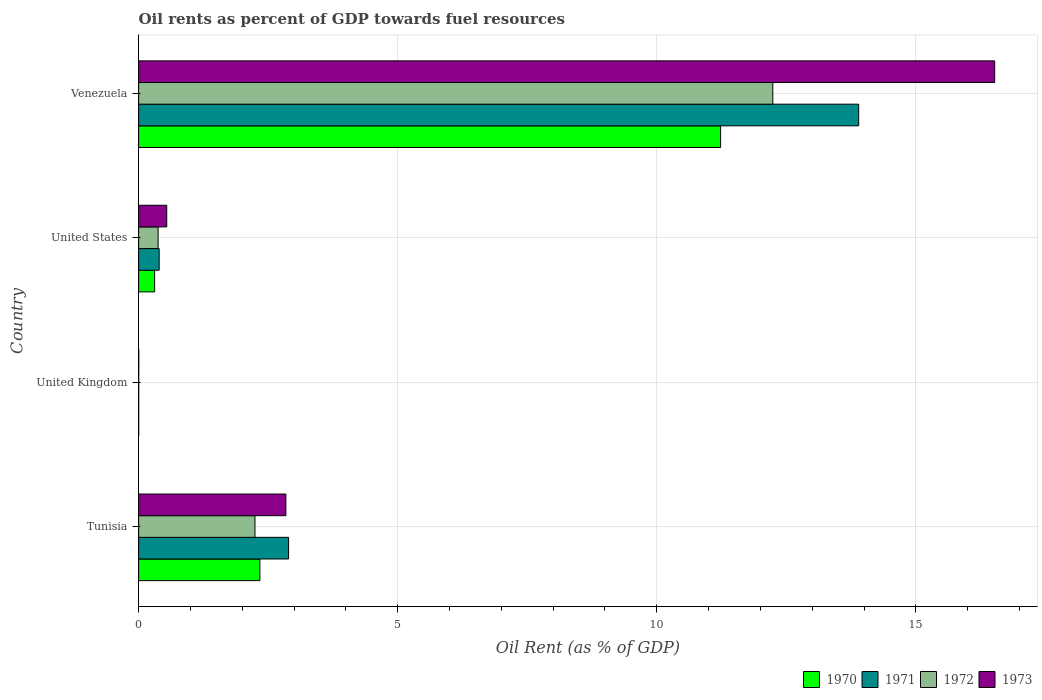How many different coloured bars are there?
Your answer should be very brief. 4. How many groups of bars are there?
Your answer should be compact. 4. Are the number of bars on each tick of the Y-axis equal?
Your answer should be compact. Yes. How many bars are there on the 3rd tick from the bottom?
Provide a short and direct response. 4. In how many cases, is the number of bars for a given country not equal to the number of legend labels?
Provide a short and direct response. 0. What is the oil rent in 1970 in Venezuela?
Give a very brief answer. 11.23. Across all countries, what is the maximum oil rent in 1970?
Keep it short and to the point. 11.23. Across all countries, what is the minimum oil rent in 1971?
Your answer should be very brief. 0. In which country was the oil rent in 1971 maximum?
Make the answer very short. Venezuela. In which country was the oil rent in 1971 minimum?
Your answer should be very brief. United Kingdom. What is the total oil rent in 1973 in the graph?
Provide a succinct answer. 19.91. What is the difference between the oil rent in 1970 in Tunisia and that in United States?
Offer a very short reply. 2.03. What is the difference between the oil rent in 1973 in United States and the oil rent in 1971 in Venezuela?
Offer a very short reply. -13.35. What is the average oil rent in 1972 per country?
Ensure brevity in your answer.  3.72. What is the difference between the oil rent in 1972 and oil rent in 1970 in United Kingdom?
Ensure brevity in your answer.  0. What is the ratio of the oil rent in 1973 in Tunisia to that in Venezuela?
Your answer should be very brief. 0.17. What is the difference between the highest and the second highest oil rent in 1973?
Provide a succinct answer. 13.68. What is the difference between the highest and the lowest oil rent in 1971?
Offer a terse response. 13.9. What does the 4th bar from the top in Tunisia represents?
Make the answer very short. 1970. What does the 2nd bar from the bottom in United Kingdom represents?
Keep it short and to the point. 1971. Is it the case that in every country, the sum of the oil rent in 1970 and oil rent in 1973 is greater than the oil rent in 1971?
Ensure brevity in your answer.  Yes. Are all the bars in the graph horizontal?
Provide a short and direct response. Yes. What is the difference between two consecutive major ticks on the X-axis?
Provide a short and direct response. 5. How are the legend labels stacked?
Your answer should be very brief. Horizontal. What is the title of the graph?
Offer a terse response. Oil rents as percent of GDP towards fuel resources. Does "1970" appear as one of the legend labels in the graph?
Ensure brevity in your answer.  Yes. What is the label or title of the X-axis?
Offer a very short reply. Oil Rent (as % of GDP). What is the label or title of the Y-axis?
Offer a very short reply. Country. What is the Oil Rent (as % of GDP) of 1970 in Tunisia?
Ensure brevity in your answer.  2.34. What is the Oil Rent (as % of GDP) in 1971 in Tunisia?
Offer a very short reply. 2.89. What is the Oil Rent (as % of GDP) in 1972 in Tunisia?
Offer a terse response. 2.25. What is the Oil Rent (as % of GDP) in 1973 in Tunisia?
Your answer should be very brief. 2.84. What is the Oil Rent (as % of GDP) in 1970 in United Kingdom?
Ensure brevity in your answer.  0. What is the Oil Rent (as % of GDP) in 1971 in United Kingdom?
Your response must be concise. 0. What is the Oil Rent (as % of GDP) of 1972 in United Kingdom?
Make the answer very short. 0. What is the Oil Rent (as % of GDP) of 1973 in United Kingdom?
Your response must be concise. 0. What is the Oil Rent (as % of GDP) of 1970 in United States?
Offer a very short reply. 0.31. What is the Oil Rent (as % of GDP) in 1971 in United States?
Ensure brevity in your answer.  0.4. What is the Oil Rent (as % of GDP) of 1972 in United States?
Provide a short and direct response. 0.38. What is the Oil Rent (as % of GDP) in 1973 in United States?
Your response must be concise. 0.54. What is the Oil Rent (as % of GDP) of 1970 in Venezuela?
Provide a succinct answer. 11.23. What is the Oil Rent (as % of GDP) of 1971 in Venezuela?
Keep it short and to the point. 13.9. What is the Oil Rent (as % of GDP) in 1972 in Venezuela?
Offer a terse response. 12.24. What is the Oil Rent (as % of GDP) in 1973 in Venezuela?
Make the answer very short. 16.52. Across all countries, what is the maximum Oil Rent (as % of GDP) of 1970?
Offer a very short reply. 11.23. Across all countries, what is the maximum Oil Rent (as % of GDP) of 1971?
Your answer should be compact. 13.9. Across all countries, what is the maximum Oil Rent (as % of GDP) of 1972?
Keep it short and to the point. 12.24. Across all countries, what is the maximum Oil Rent (as % of GDP) of 1973?
Provide a succinct answer. 16.52. Across all countries, what is the minimum Oil Rent (as % of GDP) in 1970?
Make the answer very short. 0. Across all countries, what is the minimum Oil Rent (as % of GDP) in 1971?
Ensure brevity in your answer.  0. Across all countries, what is the minimum Oil Rent (as % of GDP) in 1972?
Your response must be concise. 0. Across all countries, what is the minimum Oil Rent (as % of GDP) of 1973?
Make the answer very short. 0. What is the total Oil Rent (as % of GDP) of 1970 in the graph?
Keep it short and to the point. 13.88. What is the total Oil Rent (as % of GDP) of 1971 in the graph?
Your answer should be very brief. 17.19. What is the total Oil Rent (as % of GDP) in 1972 in the graph?
Give a very brief answer. 14.86. What is the total Oil Rent (as % of GDP) of 1973 in the graph?
Ensure brevity in your answer.  19.91. What is the difference between the Oil Rent (as % of GDP) of 1970 in Tunisia and that in United Kingdom?
Offer a very short reply. 2.34. What is the difference between the Oil Rent (as % of GDP) of 1971 in Tunisia and that in United Kingdom?
Your response must be concise. 2.89. What is the difference between the Oil Rent (as % of GDP) in 1972 in Tunisia and that in United Kingdom?
Ensure brevity in your answer.  2.24. What is the difference between the Oil Rent (as % of GDP) of 1973 in Tunisia and that in United Kingdom?
Provide a succinct answer. 2.84. What is the difference between the Oil Rent (as % of GDP) of 1970 in Tunisia and that in United States?
Offer a terse response. 2.03. What is the difference between the Oil Rent (as % of GDP) of 1971 in Tunisia and that in United States?
Keep it short and to the point. 2.5. What is the difference between the Oil Rent (as % of GDP) of 1972 in Tunisia and that in United States?
Offer a very short reply. 1.87. What is the difference between the Oil Rent (as % of GDP) of 1973 in Tunisia and that in United States?
Ensure brevity in your answer.  2.3. What is the difference between the Oil Rent (as % of GDP) in 1970 in Tunisia and that in Venezuela?
Offer a very short reply. -8.89. What is the difference between the Oil Rent (as % of GDP) of 1971 in Tunisia and that in Venezuela?
Give a very brief answer. -11. What is the difference between the Oil Rent (as % of GDP) in 1972 in Tunisia and that in Venezuela?
Make the answer very short. -9.99. What is the difference between the Oil Rent (as % of GDP) in 1973 in Tunisia and that in Venezuela?
Provide a short and direct response. -13.68. What is the difference between the Oil Rent (as % of GDP) of 1970 in United Kingdom and that in United States?
Make the answer very short. -0.31. What is the difference between the Oil Rent (as % of GDP) of 1971 in United Kingdom and that in United States?
Offer a very short reply. -0.4. What is the difference between the Oil Rent (as % of GDP) in 1972 in United Kingdom and that in United States?
Your response must be concise. -0.37. What is the difference between the Oil Rent (as % of GDP) of 1973 in United Kingdom and that in United States?
Your response must be concise. -0.54. What is the difference between the Oil Rent (as % of GDP) of 1970 in United Kingdom and that in Venezuela?
Offer a very short reply. -11.23. What is the difference between the Oil Rent (as % of GDP) of 1971 in United Kingdom and that in Venezuela?
Offer a terse response. -13.9. What is the difference between the Oil Rent (as % of GDP) of 1972 in United Kingdom and that in Venezuela?
Give a very brief answer. -12.24. What is the difference between the Oil Rent (as % of GDP) of 1973 in United Kingdom and that in Venezuela?
Ensure brevity in your answer.  -16.52. What is the difference between the Oil Rent (as % of GDP) of 1970 in United States and that in Venezuela?
Offer a terse response. -10.92. What is the difference between the Oil Rent (as % of GDP) in 1971 in United States and that in Venezuela?
Make the answer very short. -13.5. What is the difference between the Oil Rent (as % of GDP) of 1972 in United States and that in Venezuela?
Your answer should be compact. -11.86. What is the difference between the Oil Rent (as % of GDP) of 1973 in United States and that in Venezuela?
Your response must be concise. -15.98. What is the difference between the Oil Rent (as % of GDP) of 1970 in Tunisia and the Oil Rent (as % of GDP) of 1971 in United Kingdom?
Offer a terse response. 2.34. What is the difference between the Oil Rent (as % of GDP) of 1970 in Tunisia and the Oil Rent (as % of GDP) of 1972 in United Kingdom?
Keep it short and to the point. 2.34. What is the difference between the Oil Rent (as % of GDP) of 1970 in Tunisia and the Oil Rent (as % of GDP) of 1973 in United Kingdom?
Your response must be concise. 2.34. What is the difference between the Oil Rent (as % of GDP) of 1971 in Tunisia and the Oil Rent (as % of GDP) of 1972 in United Kingdom?
Provide a succinct answer. 2.89. What is the difference between the Oil Rent (as % of GDP) in 1971 in Tunisia and the Oil Rent (as % of GDP) in 1973 in United Kingdom?
Offer a terse response. 2.89. What is the difference between the Oil Rent (as % of GDP) of 1972 in Tunisia and the Oil Rent (as % of GDP) of 1973 in United Kingdom?
Give a very brief answer. 2.24. What is the difference between the Oil Rent (as % of GDP) of 1970 in Tunisia and the Oil Rent (as % of GDP) of 1971 in United States?
Provide a short and direct response. 1.94. What is the difference between the Oil Rent (as % of GDP) of 1970 in Tunisia and the Oil Rent (as % of GDP) of 1972 in United States?
Provide a short and direct response. 1.96. What is the difference between the Oil Rent (as % of GDP) of 1970 in Tunisia and the Oil Rent (as % of GDP) of 1973 in United States?
Offer a very short reply. 1.8. What is the difference between the Oil Rent (as % of GDP) in 1971 in Tunisia and the Oil Rent (as % of GDP) in 1972 in United States?
Provide a short and direct response. 2.52. What is the difference between the Oil Rent (as % of GDP) of 1971 in Tunisia and the Oil Rent (as % of GDP) of 1973 in United States?
Give a very brief answer. 2.35. What is the difference between the Oil Rent (as % of GDP) in 1972 in Tunisia and the Oil Rent (as % of GDP) in 1973 in United States?
Offer a very short reply. 1.7. What is the difference between the Oil Rent (as % of GDP) of 1970 in Tunisia and the Oil Rent (as % of GDP) of 1971 in Venezuela?
Your answer should be compact. -11.56. What is the difference between the Oil Rent (as % of GDP) in 1970 in Tunisia and the Oil Rent (as % of GDP) in 1972 in Venezuela?
Your response must be concise. -9.9. What is the difference between the Oil Rent (as % of GDP) in 1970 in Tunisia and the Oil Rent (as % of GDP) in 1973 in Venezuela?
Offer a very short reply. -14.18. What is the difference between the Oil Rent (as % of GDP) of 1971 in Tunisia and the Oil Rent (as % of GDP) of 1972 in Venezuela?
Offer a terse response. -9.35. What is the difference between the Oil Rent (as % of GDP) of 1971 in Tunisia and the Oil Rent (as % of GDP) of 1973 in Venezuela?
Offer a terse response. -13.63. What is the difference between the Oil Rent (as % of GDP) of 1972 in Tunisia and the Oil Rent (as % of GDP) of 1973 in Venezuela?
Your response must be concise. -14.28. What is the difference between the Oil Rent (as % of GDP) of 1970 in United Kingdom and the Oil Rent (as % of GDP) of 1971 in United States?
Keep it short and to the point. -0.4. What is the difference between the Oil Rent (as % of GDP) in 1970 in United Kingdom and the Oil Rent (as % of GDP) in 1972 in United States?
Give a very brief answer. -0.38. What is the difference between the Oil Rent (as % of GDP) of 1970 in United Kingdom and the Oil Rent (as % of GDP) of 1973 in United States?
Offer a terse response. -0.54. What is the difference between the Oil Rent (as % of GDP) in 1971 in United Kingdom and the Oil Rent (as % of GDP) in 1972 in United States?
Offer a terse response. -0.38. What is the difference between the Oil Rent (as % of GDP) of 1971 in United Kingdom and the Oil Rent (as % of GDP) of 1973 in United States?
Keep it short and to the point. -0.54. What is the difference between the Oil Rent (as % of GDP) in 1972 in United Kingdom and the Oil Rent (as % of GDP) in 1973 in United States?
Ensure brevity in your answer.  -0.54. What is the difference between the Oil Rent (as % of GDP) in 1970 in United Kingdom and the Oil Rent (as % of GDP) in 1971 in Venezuela?
Offer a very short reply. -13.9. What is the difference between the Oil Rent (as % of GDP) in 1970 in United Kingdom and the Oil Rent (as % of GDP) in 1972 in Venezuela?
Offer a terse response. -12.24. What is the difference between the Oil Rent (as % of GDP) in 1970 in United Kingdom and the Oil Rent (as % of GDP) in 1973 in Venezuela?
Make the answer very short. -16.52. What is the difference between the Oil Rent (as % of GDP) of 1971 in United Kingdom and the Oil Rent (as % of GDP) of 1972 in Venezuela?
Provide a succinct answer. -12.24. What is the difference between the Oil Rent (as % of GDP) of 1971 in United Kingdom and the Oil Rent (as % of GDP) of 1973 in Venezuela?
Provide a succinct answer. -16.52. What is the difference between the Oil Rent (as % of GDP) of 1972 in United Kingdom and the Oil Rent (as % of GDP) of 1973 in Venezuela?
Your response must be concise. -16.52. What is the difference between the Oil Rent (as % of GDP) in 1970 in United States and the Oil Rent (as % of GDP) in 1971 in Venezuela?
Your response must be concise. -13.59. What is the difference between the Oil Rent (as % of GDP) of 1970 in United States and the Oil Rent (as % of GDP) of 1972 in Venezuela?
Your answer should be compact. -11.93. What is the difference between the Oil Rent (as % of GDP) in 1970 in United States and the Oil Rent (as % of GDP) in 1973 in Venezuela?
Offer a very short reply. -16.21. What is the difference between the Oil Rent (as % of GDP) in 1971 in United States and the Oil Rent (as % of GDP) in 1972 in Venezuela?
Make the answer very short. -11.84. What is the difference between the Oil Rent (as % of GDP) of 1971 in United States and the Oil Rent (as % of GDP) of 1973 in Venezuela?
Give a very brief answer. -16.12. What is the difference between the Oil Rent (as % of GDP) in 1972 in United States and the Oil Rent (as % of GDP) in 1973 in Venezuela?
Your response must be concise. -16.15. What is the average Oil Rent (as % of GDP) of 1970 per country?
Provide a short and direct response. 3.47. What is the average Oil Rent (as % of GDP) of 1971 per country?
Provide a short and direct response. 4.3. What is the average Oil Rent (as % of GDP) in 1972 per country?
Your response must be concise. 3.72. What is the average Oil Rent (as % of GDP) of 1973 per country?
Give a very brief answer. 4.98. What is the difference between the Oil Rent (as % of GDP) of 1970 and Oil Rent (as % of GDP) of 1971 in Tunisia?
Keep it short and to the point. -0.55. What is the difference between the Oil Rent (as % of GDP) of 1970 and Oil Rent (as % of GDP) of 1972 in Tunisia?
Make the answer very short. 0.1. What is the difference between the Oil Rent (as % of GDP) in 1970 and Oil Rent (as % of GDP) in 1973 in Tunisia?
Give a very brief answer. -0.5. What is the difference between the Oil Rent (as % of GDP) of 1971 and Oil Rent (as % of GDP) of 1972 in Tunisia?
Ensure brevity in your answer.  0.65. What is the difference between the Oil Rent (as % of GDP) of 1971 and Oil Rent (as % of GDP) of 1973 in Tunisia?
Offer a very short reply. 0.05. What is the difference between the Oil Rent (as % of GDP) of 1972 and Oil Rent (as % of GDP) of 1973 in Tunisia?
Offer a very short reply. -0.6. What is the difference between the Oil Rent (as % of GDP) of 1970 and Oil Rent (as % of GDP) of 1972 in United Kingdom?
Give a very brief answer. -0. What is the difference between the Oil Rent (as % of GDP) in 1970 and Oil Rent (as % of GDP) in 1973 in United Kingdom?
Provide a short and direct response. -0. What is the difference between the Oil Rent (as % of GDP) in 1971 and Oil Rent (as % of GDP) in 1972 in United Kingdom?
Offer a terse response. -0. What is the difference between the Oil Rent (as % of GDP) of 1971 and Oil Rent (as % of GDP) of 1973 in United Kingdom?
Give a very brief answer. -0. What is the difference between the Oil Rent (as % of GDP) of 1972 and Oil Rent (as % of GDP) of 1973 in United Kingdom?
Offer a very short reply. -0. What is the difference between the Oil Rent (as % of GDP) in 1970 and Oil Rent (as % of GDP) in 1971 in United States?
Offer a terse response. -0.09. What is the difference between the Oil Rent (as % of GDP) of 1970 and Oil Rent (as % of GDP) of 1972 in United States?
Offer a terse response. -0.07. What is the difference between the Oil Rent (as % of GDP) of 1970 and Oil Rent (as % of GDP) of 1973 in United States?
Your answer should be compact. -0.23. What is the difference between the Oil Rent (as % of GDP) of 1971 and Oil Rent (as % of GDP) of 1972 in United States?
Provide a short and direct response. 0.02. What is the difference between the Oil Rent (as % of GDP) of 1971 and Oil Rent (as % of GDP) of 1973 in United States?
Offer a very short reply. -0.15. What is the difference between the Oil Rent (as % of GDP) in 1972 and Oil Rent (as % of GDP) in 1973 in United States?
Your response must be concise. -0.17. What is the difference between the Oil Rent (as % of GDP) of 1970 and Oil Rent (as % of GDP) of 1971 in Venezuela?
Your answer should be compact. -2.67. What is the difference between the Oil Rent (as % of GDP) of 1970 and Oil Rent (as % of GDP) of 1972 in Venezuela?
Offer a terse response. -1.01. What is the difference between the Oil Rent (as % of GDP) of 1970 and Oil Rent (as % of GDP) of 1973 in Venezuela?
Your response must be concise. -5.29. What is the difference between the Oil Rent (as % of GDP) of 1971 and Oil Rent (as % of GDP) of 1972 in Venezuela?
Your response must be concise. 1.66. What is the difference between the Oil Rent (as % of GDP) of 1971 and Oil Rent (as % of GDP) of 1973 in Venezuela?
Your answer should be very brief. -2.62. What is the difference between the Oil Rent (as % of GDP) of 1972 and Oil Rent (as % of GDP) of 1973 in Venezuela?
Offer a terse response. -4.28. What is the ratio of the Oil Rent (as % of GDP) in 1970 in Tunisia to that in United Kingdom?
Keep it short and to the point. 2642.42. What is the ratio of the Oil Rent (as % of GDP) of 1971 in Tunisia to that in United Kingdom?
Make the answer very short. 4088.61. What is the ratio of the Oil Rent (as % of GDP) in 1972 in Tunisia to that in United Kingdom?
Your response must be concise. 1735.44. What is the ratio of the Oil Rent (as % of GDP) of 1973 in Tunisia to that in United Kingdom?
Keep it short and to the point. 1266.39. What is the ratio of the Oil Rent (as % of GDP) of 1970 in Tunisia to that in United States?
Offer a very short reply. 7.59. What is the ratio of the Oil Rent (as % of GDP) in 1971 in Tunisia to that in United States?
Provide a short and direct response. 7.3. What is the ratio of the Oil Rent (as % of GDP) in 1972 in Tunisia to that in United States?
Your answer should be compact. 5.97. What is the ratio of the Oil Rent (as % of GDP) of 1973 in Tunisia to that in United States?
Offer a very short reply. 5.24. What is the ratio of the Oil Rent (as % of GDP) of 1970 in Tunisia to that in Venezuela?
Your answer should be compact. 0.21. What is the ratio of the Oil Rent (as % of GDP) in 1971 in Tunisia to that in Venezuela?
Your answer should be very brief. 0.21. What is the ratio of the Oil Rent (as % of GDP) of 1972 in Tunisia to that in Venezuela?
Provide a succinct answer. 0.18. What is the ratio of the Oil Rent (as % of GDP) in 1973 in Tunisia to that in Venezuela?
Your response must be concise. 0.17. What is the ratio of the Oil Rent (as % of GDP) in 1970 in United Kingdom to that in United States?
Provide a succinct answer. 0. What is the ratio of the Oil Rent (as % of GDP) of 1971 in United Kingdom to that in United States?
Your answer should be compact. 0. What is the ratio of the Oil Rent (as % of GDP) in 1972 in United Kingdom to that in United States?
Provide a succinct answer. 0. What is the ratio of the Oil Rent (as % of GDP) in 1973 in United Kingdom to that in United States?
Make the answer very short. 0. What is the ratio of the Oil Rent (as % of GDP) in 1970 in United Kingdom to that in Venezuela?
Provide a short and direct response. 0. What is the ratio of the Oil Rent (as % of GDP) of 1973 in United Kingdom to that in Venezuela?
Your answer should be very brief. 0. What is the ratio of the Oil Rent (as % of GDP) in 1970 in United States to that in Venezuela?
Your response must be concise. 0.03. What is the ratio of the Oil Rent (as % of GDP) of 1971 in United States to that in Venezuela?
Your answer should be very brief. 0.03. What is the ratio of the Oil Rent (as % of GDP) in 1972 in United States to that in Venezuela?
Your answer should be very brief. 0.03. What is the ratio of the Oil Rent (as % of GDP) of 1973 in United States to that in Venezuela?
Offer a very short reply. 0.03. What is the difference between the highest and the second highest Oil Rent (as % of GDP) in 1970?
Make the answer very short. 8.89. What is the difference between the highest and the second highest Oil Rent (as % of GDP) of 1971?
Your response must be concise. 11. What is the difference between the highest and the second highest Oil Rent (as % of GDP) in 1972?
Make the answer very short. 9.99. What is the difference between the highest and the second highest Oil Rent (as % of GDP) of 1973?
Provide a succinct answer. 13.68. What is the difference between the highest and the lowest Oil Rent (as % of GDP) of 1970?
Your answer should be very brief. 11.23. What is the difference between the highest and the lowest Oil Rent (as % of GDP) in 1971?
Keep it short and to the point. 13.9. What is the difference between the highest and the lowest Oil Rent (as % of GDP) of 1972?
Your response must be concise. 12.24. What is the difference between the highest and the lowest Oil Rent (as % of GDP) in 1973?
Provide a succinct answer. 16.52. 